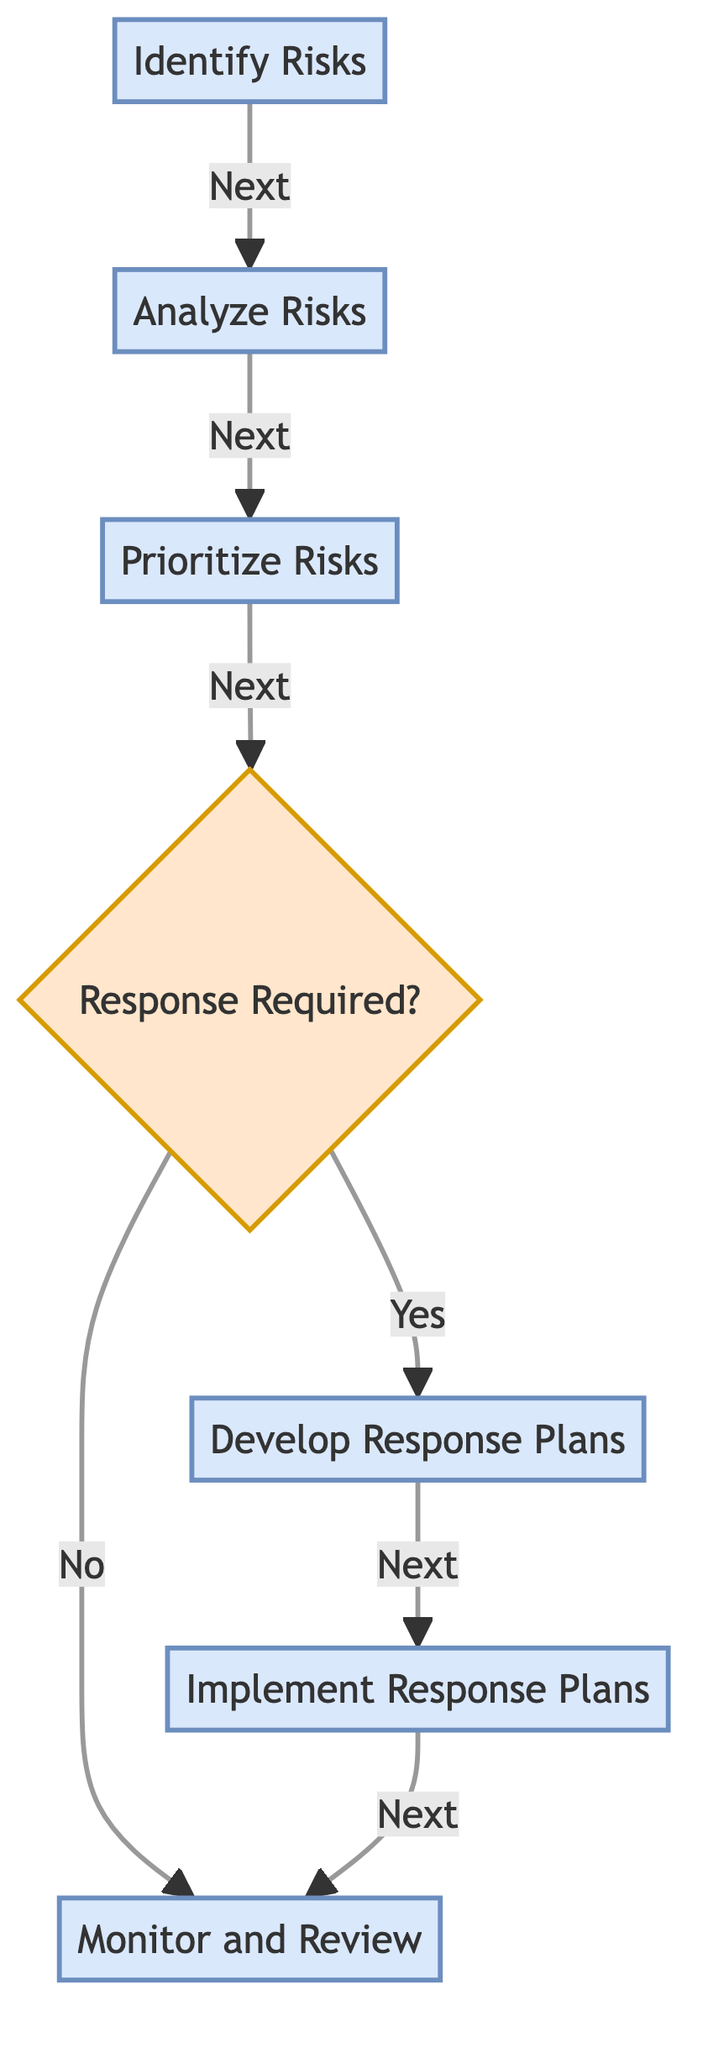What is the first step in the risk management process? The diagram shows that the first node is "Identify Risks." This is indicated as the starting point, as there are no edges leading into it.
Answer: Identify Risks How many total nodes are in the diagram? By counting all the nodes listed in the diagram, there are seven nodes that represent different stages in the risk management process.
Answer: 7 What is the label of the node that follows "Analyze Risks"? The diagram indicates that the next node after "Analyze Risks" is "Prioritize Risks," as it has a directed edge pointing to it from "Analyze Risks."
Answer: Prioritize Risks Is "Response Required?" a decision point in the process? The diagram identifies "Response Required?" as a decision point, indicated by the unique styling and the way it branches out to different nodes based on the answer.
Answer: Yes What action follows after the decision point if a response is required? The diagram shows that if a response is required, the next action is "Develop Response Plans," as indicated by the edge leading from the decision point labeled "Yes" to this node.
Answer: Develop Response Plans What happens if a response is not required after the decision point? According to the diagram, if a response is not required, the process leads directly to "Monitor and Review," indicated by the edge labeled "No" branching from the decision point.
Answer: Monitor and Review How many edges are present in the diagram? By counting each directed connection between nodes, the diagram shows that there are six edges connecting the different steps in the risk management process.
Answer: 6 What is the last step in the risk management process? The last step is "Monitor and Review," which is the final node reached in the flow of the diagram, pointing back to itself in the continuous cycle of managing risks.
Answer: Monitor and Review 